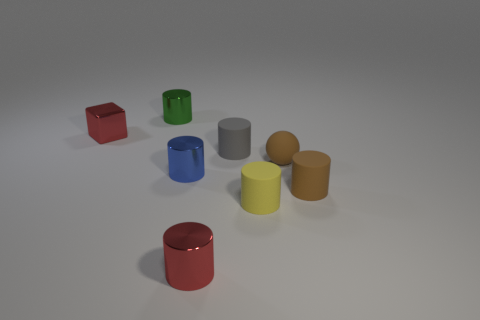What number of small objects are either green matte spheres or green shiny objects?
Ensure brevity in your answer.  1. Does the red metallic object behind the small red cylinder have the same shape as the yellow object?
Offer a terse response. No. Are there fewer gray rubber cylinders than large yellow metal spheres?
Offer a terse response. No. Is there anything else of the same color as the tiny rubber sphere?
Offer a terse response. Yes. There is a red metal object that is in front of the gray matte cylinder; what is its shape?
Your response must be concise. Cylinder. Is the color of the rubber sphere the same as the tiny metal cylinder in front of the brown rubber cylinder?
Provide a succinct answer. No. Is the number of small brown rubber things that are left of the cube the same as the number of small green cylinders behind the small blue metallic thing?
Your response must be concise. No. What number of other things are there of the same size as the green cylinder?
Offer a terse response. 7. Is the tiny yellow cylinder made of the same material as the red object that is behind the tiny gray matte cylinder?
Provide a short and direct response. No. Is there a small cyan metallic thing that has the same shape as the small green object?
Give a very brief answer. No. 